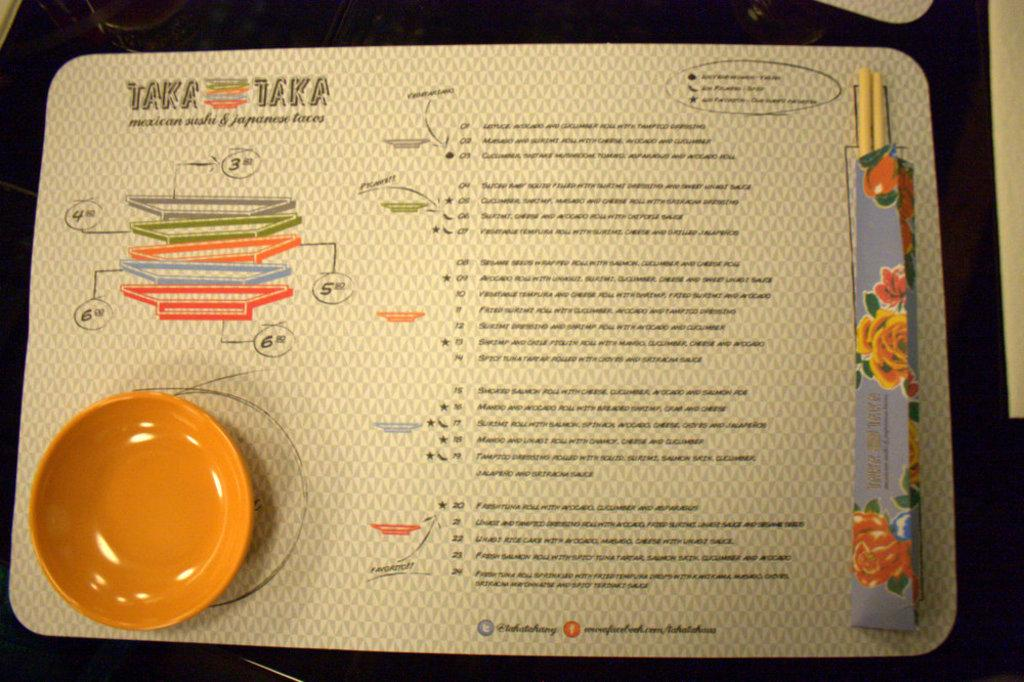What object is located on the left side of the image? There is a plate on the left side of the image. What can be seen in the middle of the image? There is text on a board in the middle of the image. Where is the scarecrow located in the image? There is no scarecrow present in the image. What type of vessel is used to transport water in the image? There is no vessel or water transportation depicted in the image. 